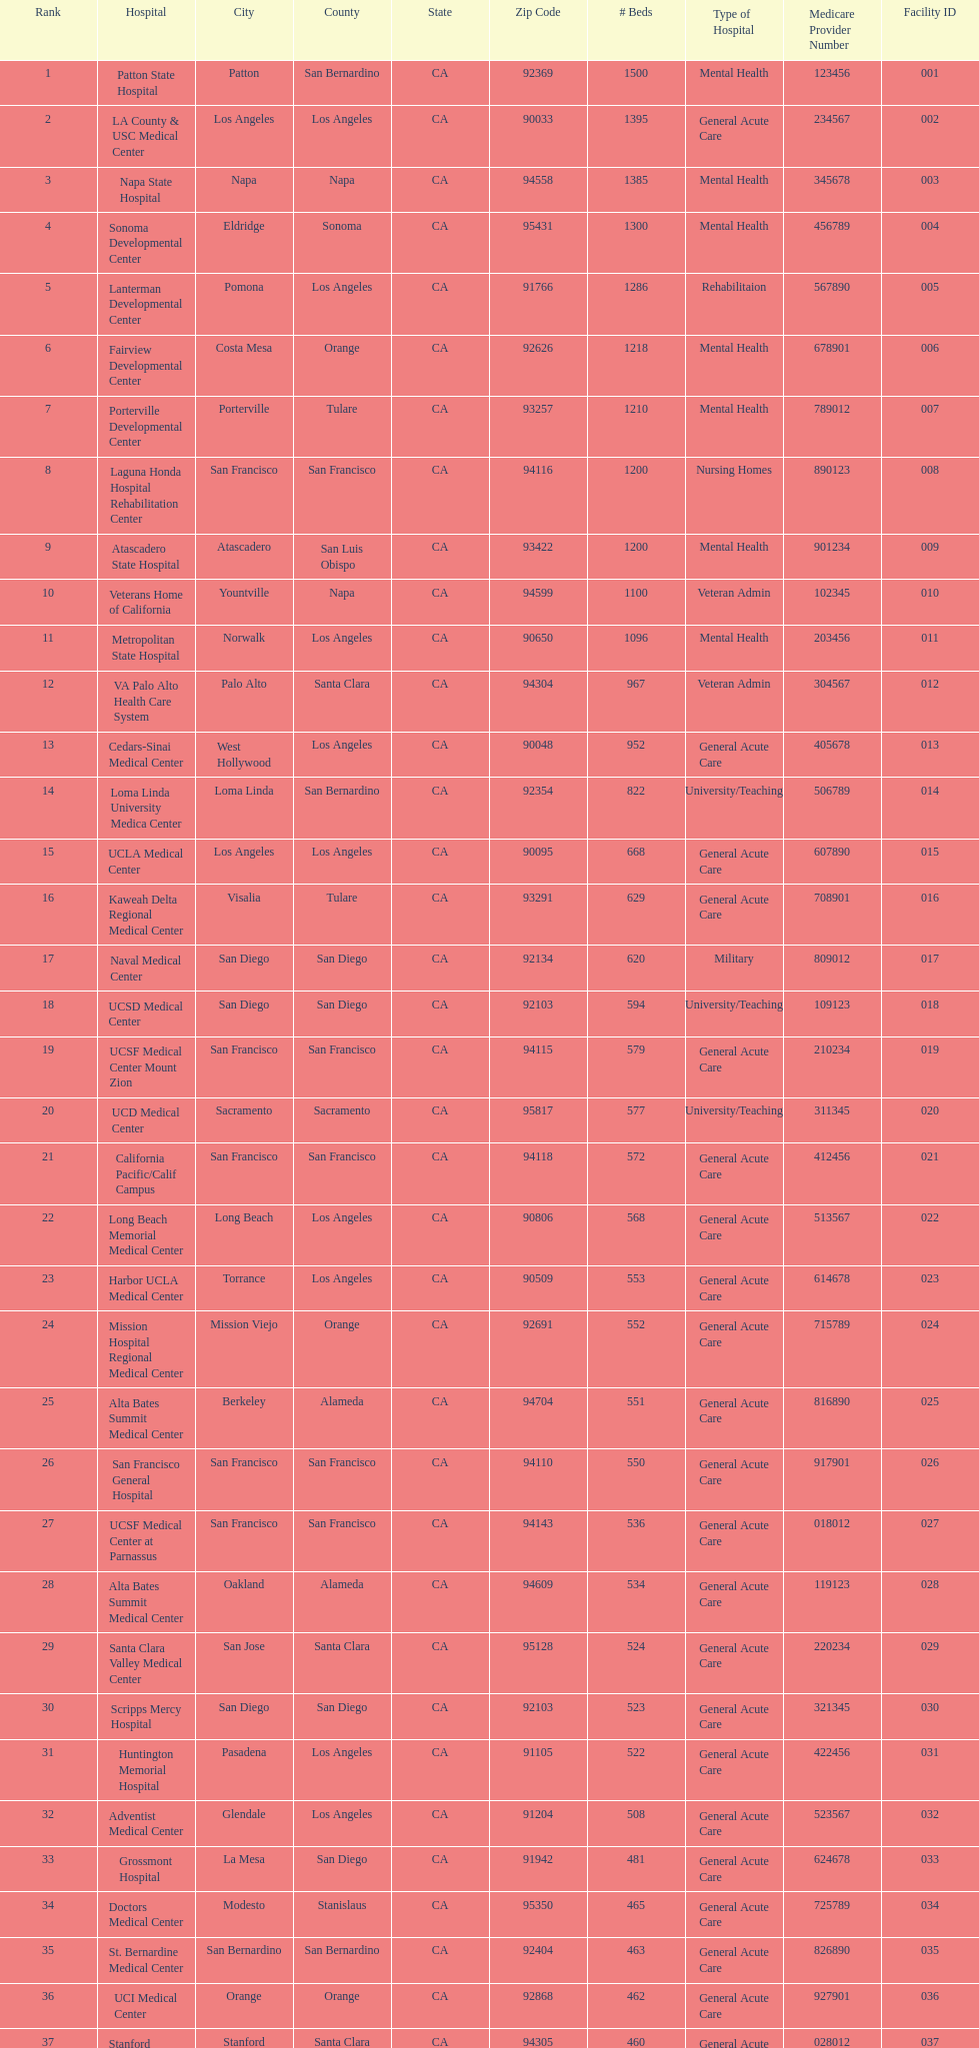Could you help me parse every detail presented in this table? {'header': ['Rank', 'Hospital', 'City', 'County', 'State', 'Zip Code', '# Beds', 'Type of Hospital', 'Medicare Provider Number', 'Facility ID'], 'rows': [['1', 'Patton State Hospital', 'Patton', 'San Bernardino', 'CA', '92369', '1500', 'Mental Health', '123456', '001'], ['2', 'LA County & USC Medical Center', 'Los Angeles', 'Los Angeles', 'CA', '90033', '1395', 'General Acute Care', '234567', '002'], ['3', 'Napa State Hospital', 'Napa', 'Napa', 'CA', '94558', '1385', 'Mental Health', '345678', '003'], ['4', 'Sonoma Developmental Center', 'Eldridge', 'Sonoma', 'CA', '95431', '1300', 'Mental Health', '456789', '004'], ['5', 'Lanterman Developmental Center', 'Pomona', 'Los Angeles', 'CA', '91766', '1286', 'Rehabilitaion', '567890', '005'], ['6', 'Fairview Developmental Center', 'Costa Mesa', 'Orange', 'CA', '92626', '1218', 'Mental Health', '678901', '006'], ['7', 'Porterville Developmental Center', 'Porterville', 'Tulare', 'CA', '93257', '1210', 'Mental Health', '789012', '007'], ['8', 'Laguna Honda Hospital Rehabilitation Center', 'San Francisco', 'San Francisco', 'CA', '94116', '1200', 'Nursing Homes', '890123', '008'], ['9', 'Atascadero State Hospital', 'Atascadero', 'San Luis Obispo', 'CA', '93422', '1200', 'Mental Health', '901234', '009'], ['10', 'Veterans Home of California', 'Yountville', 'Napa', 'CA', '94599', '1100', 'Veteran Admin', '102345', '010'], ['11', 'Metropolitan State Hospital', 'Norwalk', 'Los Angeles', 'CA', '90650', '1096', 'Mental Health', '203456', '011'], ['12', 'VA Palo Alto Health Care System', 'Palo Alto', 'Santa Clara', 'CA', '94304', '967', 'Veteran Admin', '304567', '012'], ['13', 'Cedars-Sinai Medical Center', 'West Hollywood', 'Los Angeles', 'CA', '90048', '952', 'General Acute Care', '405678', '013'], ['14', 'Loma Linda University Medica Center', 'Loma Linda', 'San Bernardino', 'CA', '92354', '822', 'University/Teaching', '506789', '014'], ['15', 'UCLA Medical Center', 'Los Angeles', 'Los Angeles', 'CA', '90095', '668', 'General Acute Care', '607890', '015'], ['16', 'Kaweah Delta Regional Medical Center', 'Visalia', 'Tulare', 'CA', '93291', '629', 'General Acute Care', '708901', '016'], ['17', 'Naval Medical Center', 'San Diego', 'San Diego', 'CA', '92134', '620', 'Military', '809012', '017'], ['18', 'UCSD Medical Center', 'San Diego', 'San Diego', 'CA', '92103', '594', 'University/Teaching', '109123', '018'], ['19', 'UCSF Medical Center Mount Zion', 'San Francisco', 'San Francisco', 'CA', '94115', '579', 'General Acute Care', '210234', '019'], ['20', 'UCD Medical Center', 'Sacramento', 'Sacramento', 'CA', '95817', '577', 'University/Teaching', '311345', '020'], ['21', 'California Pacific/Calif Campus', 'San Francisco', 'San Francisco', 'CA', '94118', '572', 'General Acute Care', '412456', '021'], ['22', 'Long Beach Memorial Medical Center', 'Long Beach', 'Los Angeles', 'CA', '90806', '568', 'General Acute Care', '513567', '022'], ['23', 'Harbor UCLA Medical Center', 'Torrance', 'Los Angeles', 'CA', '90509', '553', 'General Acute Care', '614678', '023'], ['24', 'Mission Hospital Regional Medical Center', 'Mission Viejo', 'Orange', 'CA', '92691', '552', 'General Acute Care', '715789', '024'], ['25', 'Alta Bates Summit Medical Center', 'Berkeley', 'Alameda', 'CA', '94704', '551', 'General Acute Care', '816890', '025'], ['26', 'San Francisco General Hospital', 'San Francisco', 'San Francisco', 'CA', '94110', '550', 'General Acute Care', '917901', '026'], ['27', 'UCSF Medical Center at Parnassus', 'San Francisco', 'San Francisco', 'CA', '94143', '536', 'General Acute Care', '018012', '027'], ['28', 'Alta Bates Summit Medical Center', 'Oakland', 'Alameda', 'CA', '94609', '534', 'General Acute Care', '119123', '028'], ['29', 'Santa Clara Valley Medical Center', 'San Jose', 'Santa Clara', 'CA', '95128', '524', 'General Acute Care', '220234', '029'], ['30', 'Scripps Mercy Hospital', 'San Diego', 'San Diego', 'CA', '92103', '523', 'General Acute Care', '321345', '030'], ['31', 'Huntington Memorial Hospital', 'Pasadena', 'Los Angeles', 'CA', '91105', '522', 'General Acute Care', '422456', '031'], ['32', 'Adventist Medical Center', 'Glendale', 'Los Angeles', 'CA', '91204', '508', 'General Acute Care', '523567', '032'], ['33', 'Grossmont Hospital', 'La Mesa', 'San Diego', 'CA', '91942', '481', 'General Acute Care', '624678', '033'], ['34', 'Doctors Medical Center', 'Modesto', 'Stanislaus', 'CA', '95350', '465', 'General Acute Care', '725789', '034'], ['35', 'St. Bernardine Medical Center', 'San Bernardino', 'San Bernardino', 'CA', '92404', '463', 'General Acute Care', '826890', '035'], ['36', 'UCI Medical Center', 'Orange', 'Orange', 'CA', '92868', '462', 'General Acute Care', '927901', '036'], ['37', 'Stanford Medical Center', 'Stanford', 'Santa Clara', 'CA', '94305', '460', 'General Acute Care', '028012', '037'], ['38', 'Community Regional Medical Center', 'Fresno', 'Fresno', 'CA', '93721', '457', 'General Acute Care', '129123', '038'], ['39', 'Methodist Hospital', 'Arcadia', 'Los Angeles', 'CA', '91007', '455', 'General Acute Care', '230234', '039'], ['40', 'Providence St. Joseph Medical Center', 'Burbank', 'Los Angeles', 'CA', '91505', '455', 'General Acute Care', '331345', '040'], ['41', 'Hoag Memorial Hospital', 'Newport Beach', 'Orange', 'CA', '92663', '450', 'General Acute Care', '432456', '041'], ['42', 'Agnews Developmental Center', 'San Jose', 'Santa Clara', 'CA', '95134', '450', 'Mental Health', '533567', '042'], ['43', 'Jewish Home', 'San Francisco', 'San Francisco', 'CA', '94112', '450', 'Nursing Homes', '634678', '043'], ['44', 'St. Joseph Hospital Orange', 'Orange', 'Orange', 'CA', '92868', '448', 'General Acute Care', '735789', '044'], ['45', 'Presbyterian Intercommunity', 'Whittier', 'Los Angeles', 'CA', '90602', '441', 'General Acute Care', '836890', '045'], ['46', 'Kaiser Permanente Medical Center', 'Fontana', 'San Bernardino', 'CA', '92335', '440', 'General Acute Care', '937901', '046'], ['47', 'Kaiser Permanente Medical Center', 'Los Angeles', 'Los Angeles', 'CA', '90027', '439', 'General Acute Care', '038012', '047'], ['48', 'Pomona Valley Hospital Medical Center', 'Pomona', 'Los Angeles', 'CA', '91767', '436', 'General Acute Care', '139123', '048'], ['49', 'Sutter General Medical Center', 'Sacramento', 'Sacramento', 'CA', '95819', '432', 'General Acute Care', '240234', '049'], ['50', 'St. Mary Medical Center', 'San Francisco', 'San Francisco', 'CA', '94114', '430', 'General Acute Care', '341345', '050'], ['50', 'Good Samaritan Hospital', 'San Jose', 'Santa Clara', 'CA', '95124', '429', 'General Acute Care', '442456', '051']]} Which type of hospitals are the same as grossmont hospital? General Acute Care. 